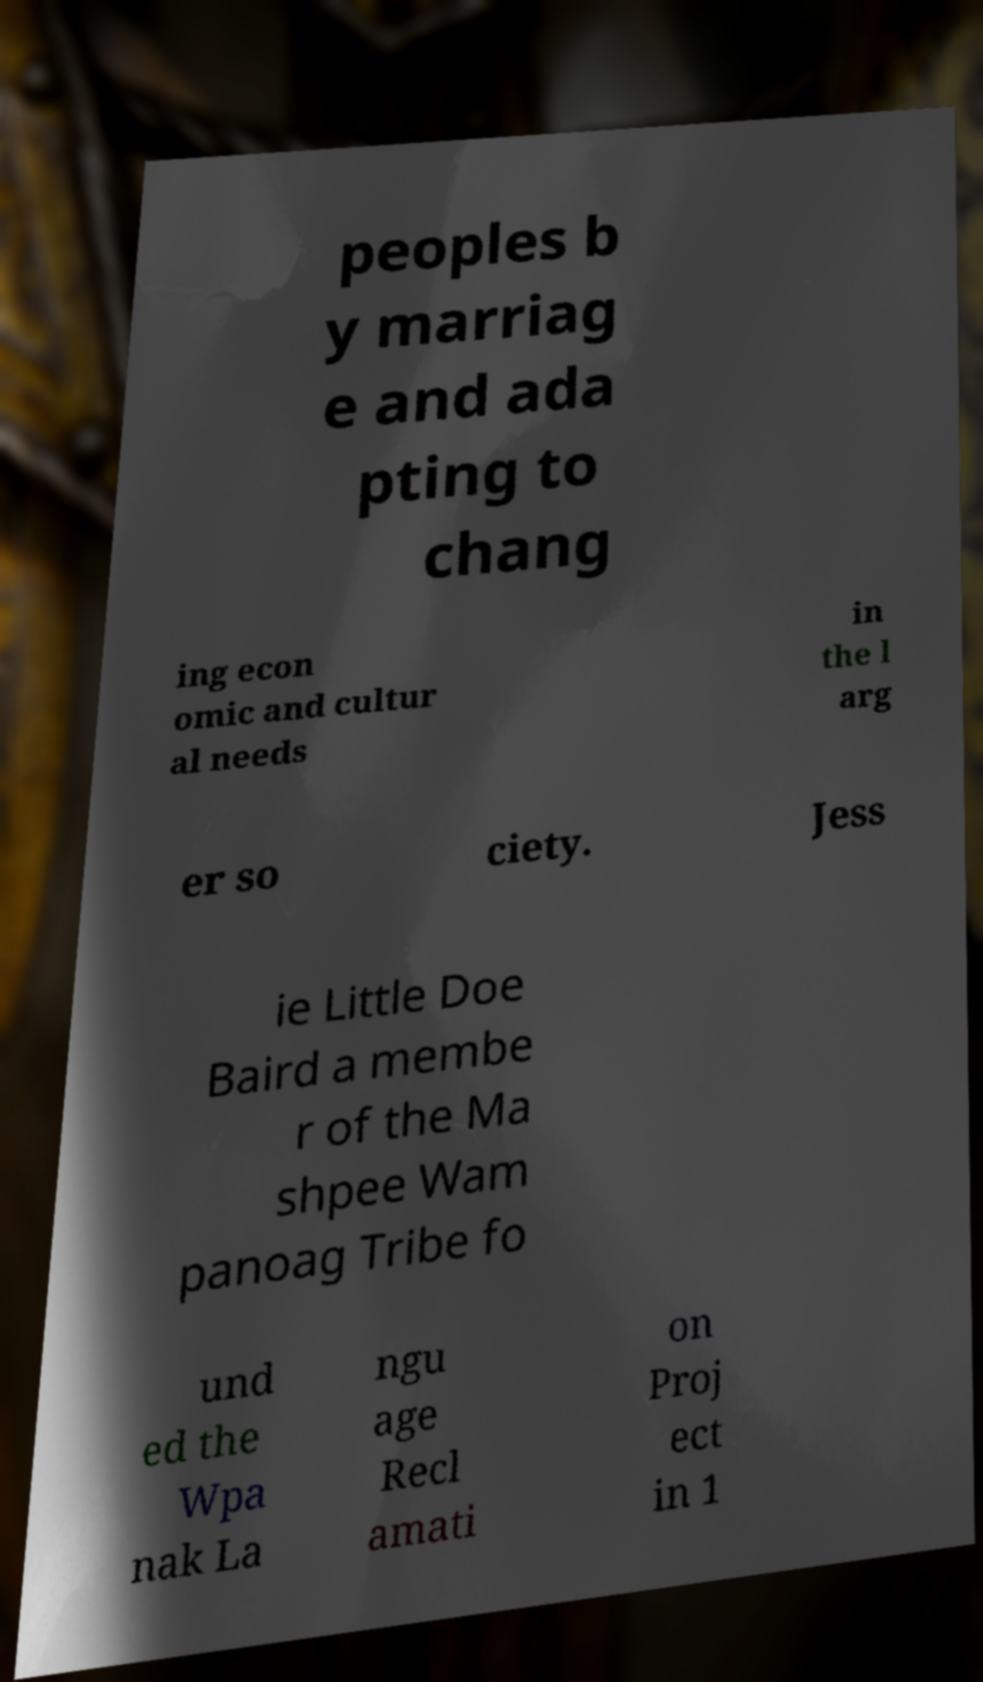Please read and relay the text visible in this image. What does it say? peoples b y marriag e and ada pting to chang ing econ omic and cultur al needs in the l arg er so ciety. Jess ie Little Doe Baird a membe r of the Ma shpee Wam panoag Tribe fo und ed the Wpa nak La ngu age Recl amati on Proj ect in 1 